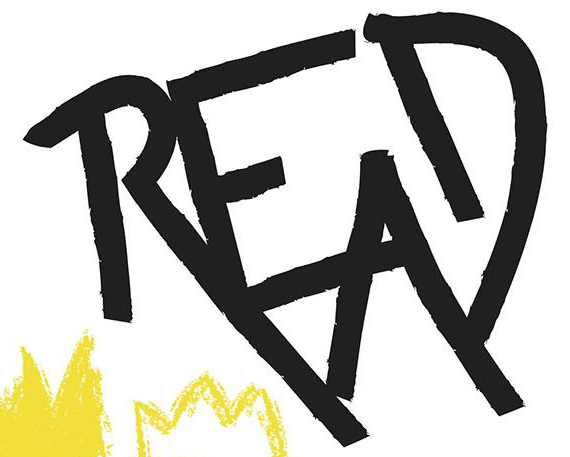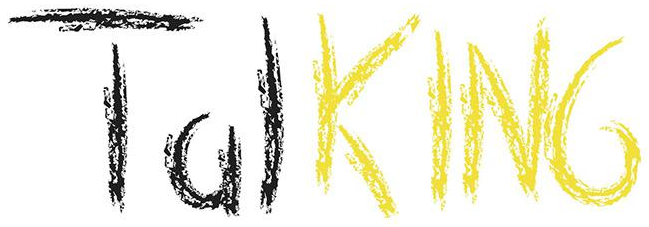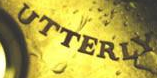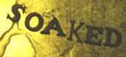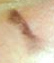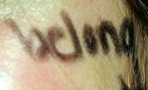What words can you see in these images in sequence, separated by a semicolon? READ; TalKING; UTTERLY; SOAKED; I; belong 